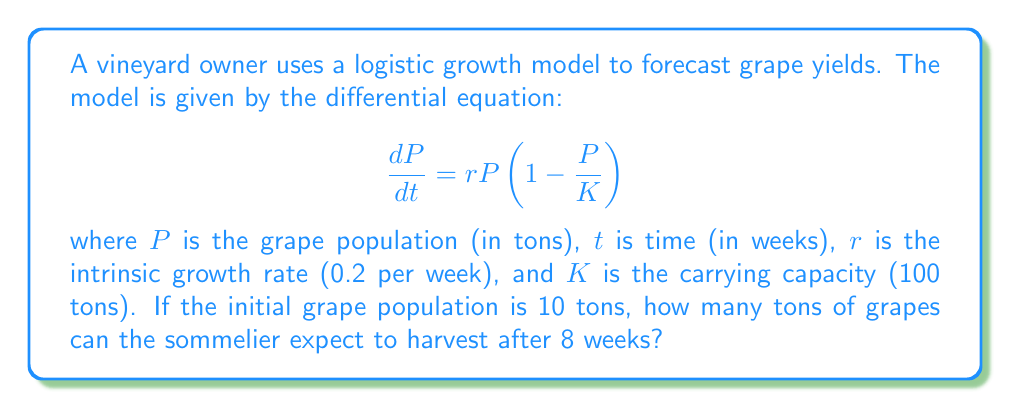Give your solution to this math problem. To solve this problem, we need to use the solution to the logistic growth model:

1. The solution to the logistic growth equation is:

   $$P(t) = \frac{KP_0e^{rt}}{K + P_0(e^{rt} - 1)}$$

   where $P_0$ is the initial population.

2. We are given:
   $K = 100$ tons
   $r = 0.2$ per week
   $P_0 = 10$ tons
   $t = 8$ weeks

3. Let's substitute these values into the equation:

   $$P(8) = \frac{100 \cdot 10 \cdot e^{0.2 \cdot 8}}{100 + 10(e^{0.2 \cdot 8} - 1)}$$

4. Calculate $e^{0.2 \cdot 8}$:
   $e^{1.6} \approx 4.9530$

5. Substitute this value:

   $$P(8) = \frac{100 \cdot 10 \cdot 4.9530}{100 + 10(4.9530 - 1)}$$

6. Simplify:

   $$P(8) = \frac{4953}{100 + 39.53} = \frac{4953}{139.53}$$

7. Calculate the final result:

   $$P(8) \approx 35.50$$ tons

Therefore, after 8 weeks, the sommelier can expect to harvest approximately 35.50 tons of grapes.
Answer: 35.50 tons 